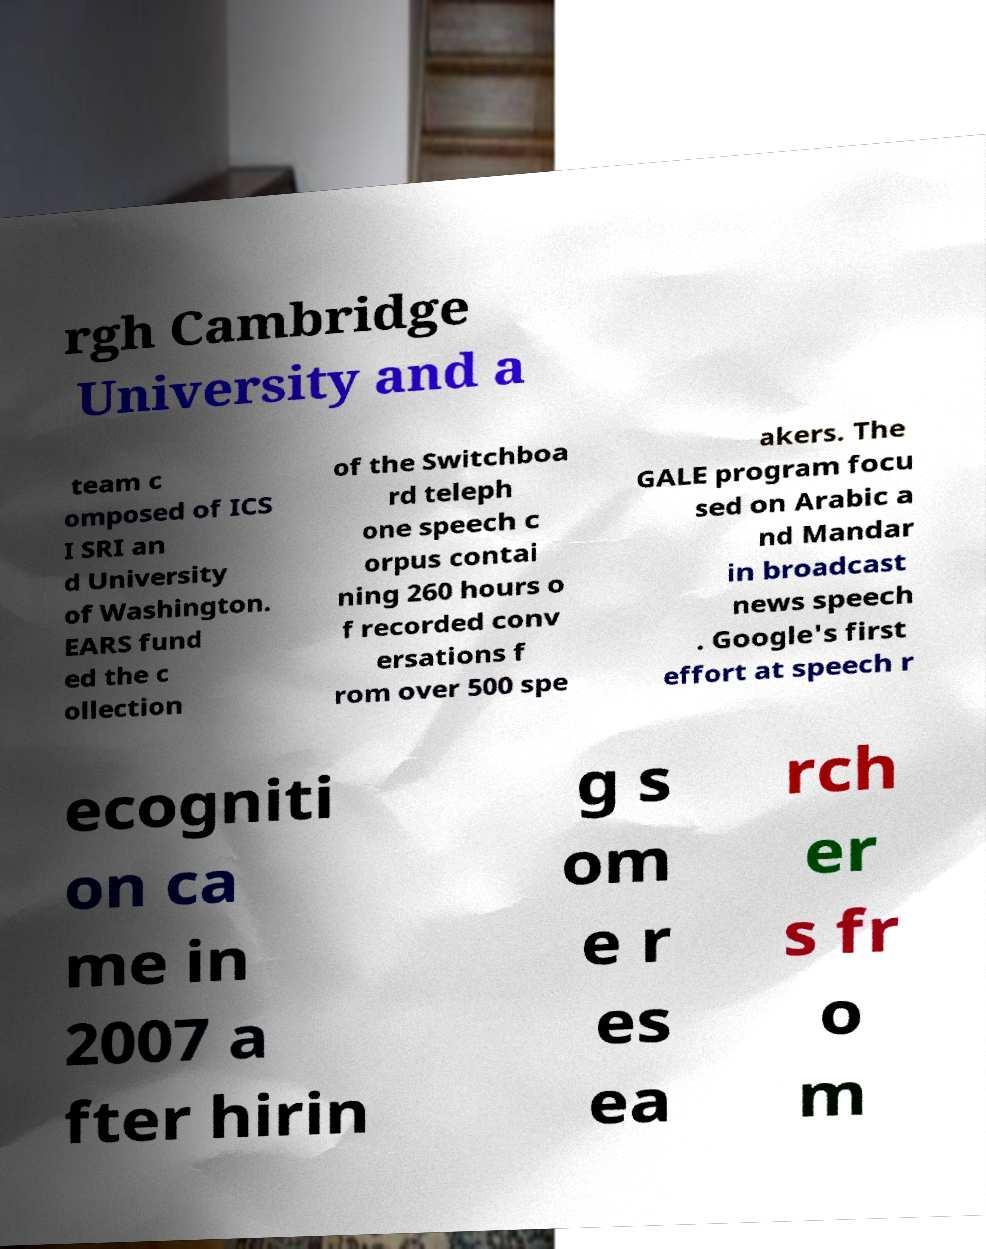Can you accurately transcribe the text from the provided image for me? rgh Cambridge University and a team c omposed of ICS I SRI an d University of Washington. EARS fund ed the c ollection of the Switchboa rd teleph one speech c orpus contai ning 260 hours o f recorded conv ersations f rom over 500 spe akers. The GALE program focu sed on Arabic a nd Mandar in broadcast news speech . Google's first effort at speech r ecogniti on ca me in 2007 a fter hirin g s om e r es ea rch er s fr o m 